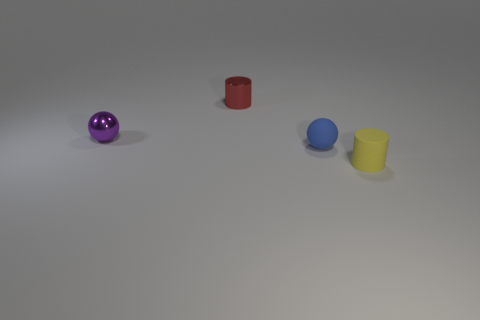Add 2 red objects. How many objects exist? 6 Add 4 matte objects. How many matte objects are left? 6 Add 2 tiny red metallic cylinders. How many tiny red metallic cylinders exist? 3 Subtract 0 green cylinders. How many objects are left? 4 Subtract all blue spheres. Subtract all tiny red objects. How many objects are left? 2 